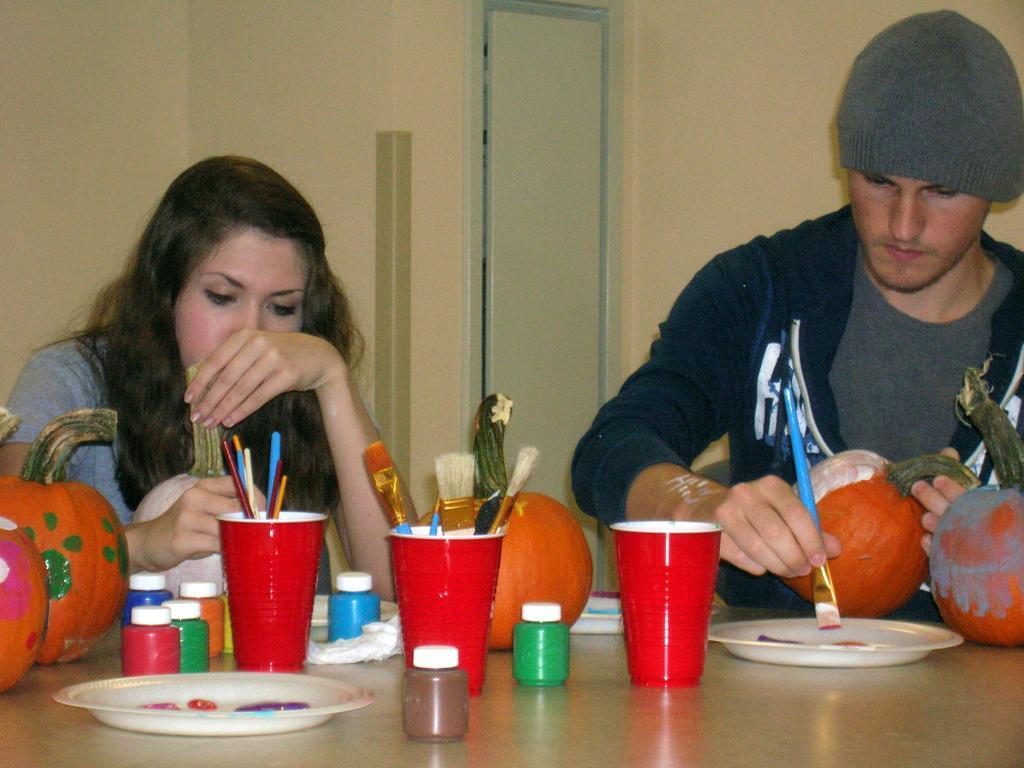Can you describe this image briefly? At the bottom of the image, on the table there are color bottles, cups with painting brushes and some other things in it. And also there are pumpkins on the table. Behind the table on the right side there is a man with a cap on his head and he is holding a painting brush in his hand. And on the left side of the image there is a lady. Behind them there are walls with a door. 